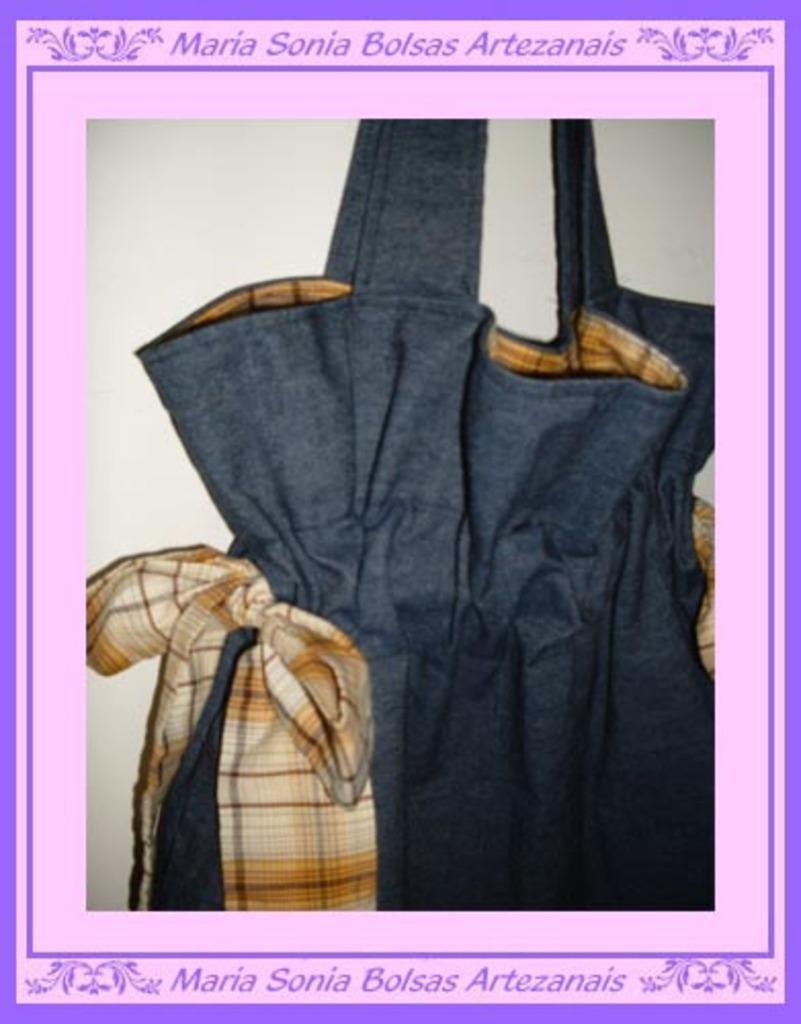Please provide a concise description of this image. This is a poster where we can see cloth in it. 